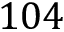Convert formula to latex. <formula><loc_0><loc_0><loc_500><loc_500>1 0 4</formula> 